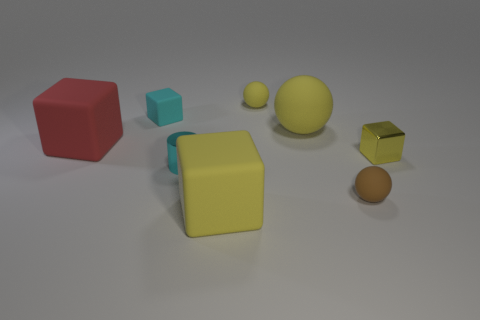Subtract all red cubes. How many cubes are left? 3 Add 2 small yellow metallic things. How many objects exist? 10 Subtract 0 gray blocks. How many objects are left? 8 Subtract all cylinders. How many objects are left? 7 Subtract all cyan rubber cubes. Subtract all tiny yellow things. How many objects are left? 5 Add 5 tiny cyan rubber blocks. How many tiny cyan rubber blocks are left? 6 Add 6 green matte spheres. How many green matte spheres exist? 6 